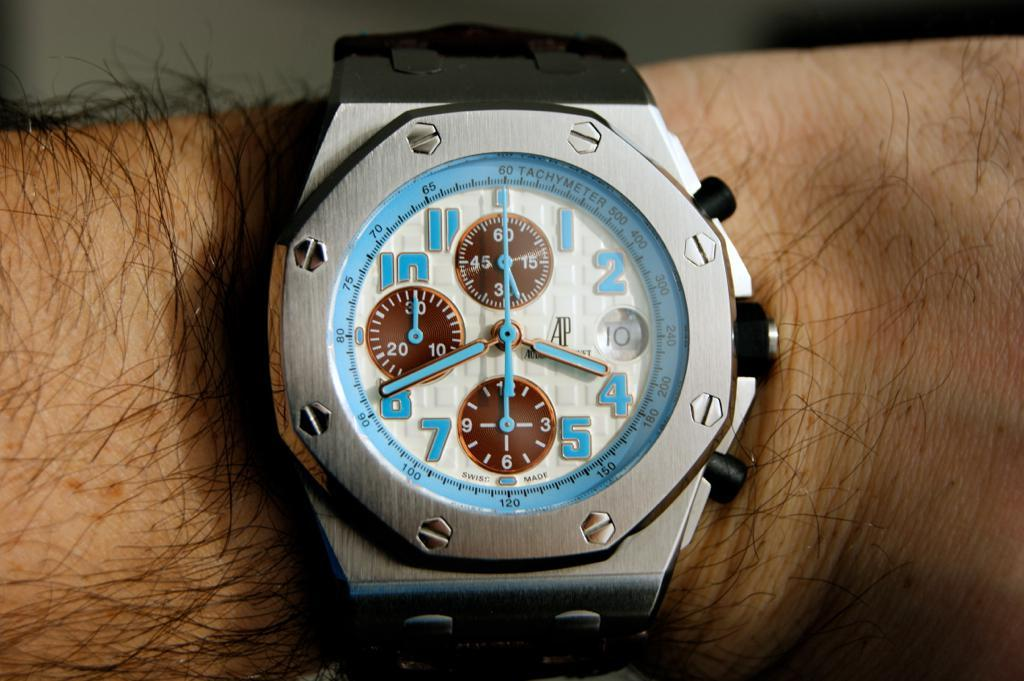Provide a one-sentence caption for the provided image. A watch face displays 4:40 on its face. 